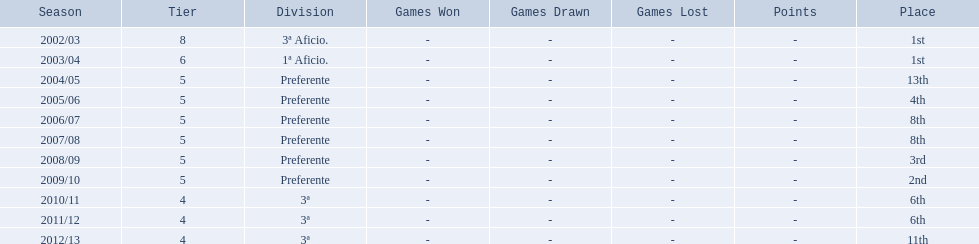How many times did  internacional de madrid cf come in 6th place? 6th, 6th. What is the first season that the team came in 6th place? 2010/11. Which season after the first did they place in 6th again? 2011/12. Can you give me this table in json format? {'header': ['Season', 'Tier', 'Division', 'Games Won', 'Games Drawn', 'Games Lost', 'Points', 'Place'], 'rows': [['2002/03', '8', '3ª Aficio.', '-', '-', '-', '-', '1st'], ['2003/04', '6', '1ª Aficio.', '-', '-', '-', '-', '1st'], ['2004/05', '5', 'Preferente', '-', '-', '-', '-', '13th'], ['2005/06', '5', 'Preferente', '-', '-', '-', '-', '4th'], ['2006/07', '5', 'Preferente', '-', '-', '-', '-', '8th'], ['2007/08', '5', 'Preferente', '-', '-', '-', '-', '8th'], ['2008/09', '5', 'Preferente', '-', '-', '-', '-', '3rd'], ['2009/10', '5', 'Preferente', '-', '-', '-', '-', '2nd'], ['2010/11', '4', '3ª', '-', '-', '-', '-', '6th'], ['2011/12', '4', '3ª', '-', '-', '-', '-', '6th'], ['2012/13', '4', '3ª', '-', '-', '-', '-', '11th']]} 